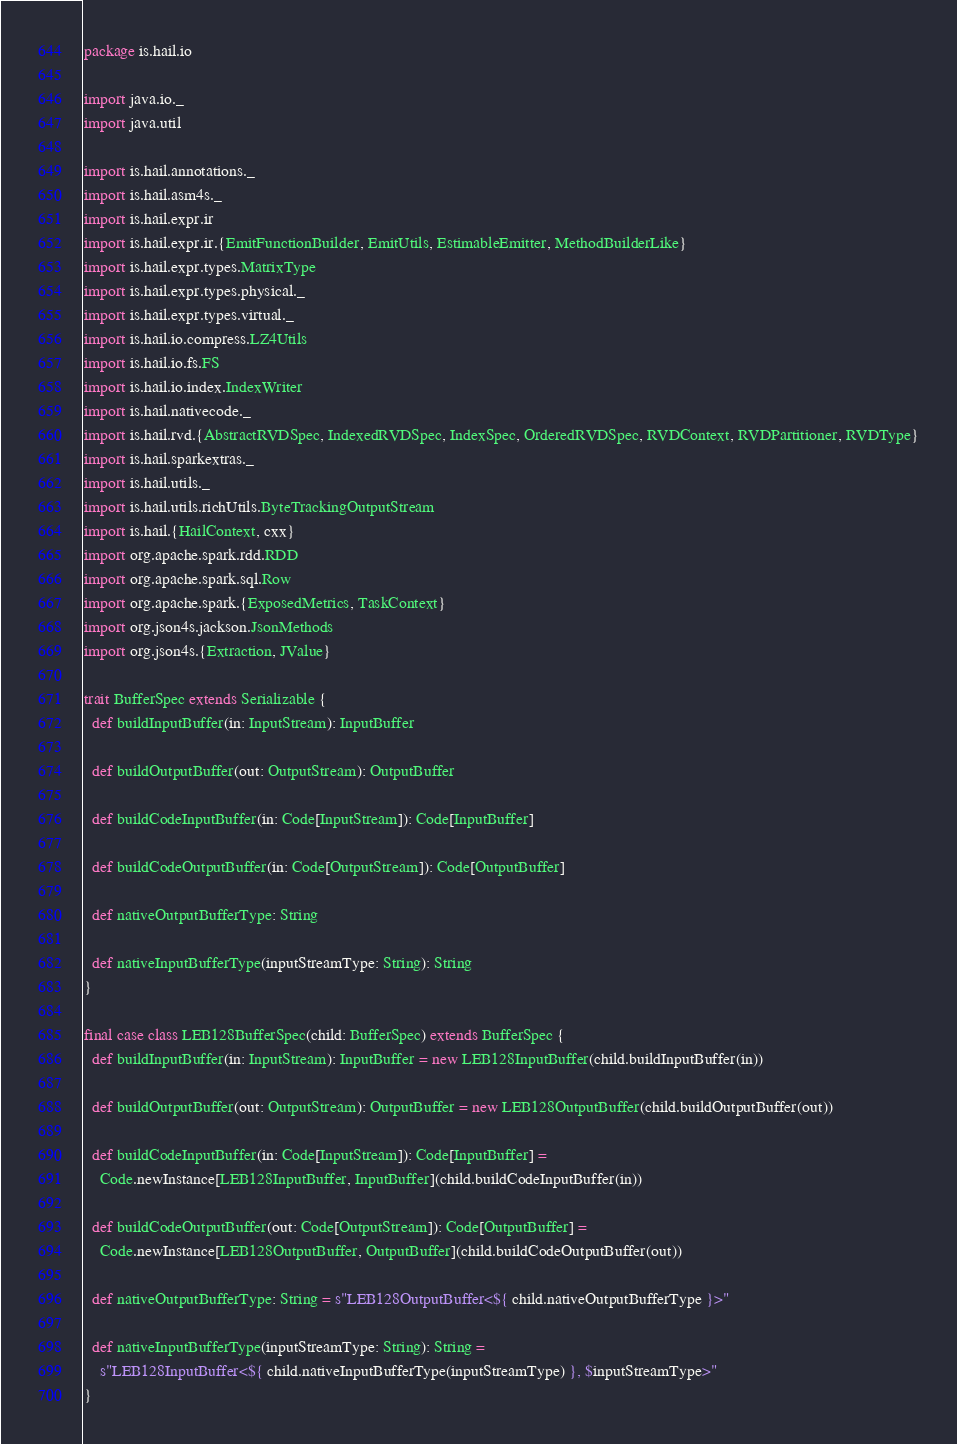Convert code to text. <code><loc_0><loc_0><loc_500><loc_500><_Scala_>package is.hail.io

import java.io._
import java.util

import is.hail.annotations._
import is.hail.asm4s._
import is.hail.expr.ir
import is.hail.expr.ir.{EmitFunctionBuilder, EmitUtils, EstimableEmitter, MethodBuilderLike}
import is.hail.expr.types.MatrixType
import is.hail.expr.types.physical._
import is.hail.expr.types.virtual._
import is.hail.io.compress.LZ4Utils
import is.hail.io.fs.FS
import is.hail.io.index.IndexWriter
import is.hail.nativecode._
import is.hail.rvd.{AbstractRVDSpec, IndexedRVDSpec, IndexSpec, OrderedRVDSpec, RVDContext, RVDPartitioner, RVDType}
import is.hail.sparkextras._
import is.hail.utils._
import is.hail.utils.richUtils.ByteTrackingOutputStream
import is.hail.{HailContext, cxx}
import org.apache.spark.rdd.RDD
import org.apache.spark.sql.Row
import org.apache.spark.{ExposedMetrics, TaskContext}
import org.json4s.jackson.JsonMethods
import org.json4s.{Extraction, JValue}

trait BufferSpec extends Serializable {
  def buildInputBuffer(in: InputStream): InputBuffer

  def buildOutputBuffer(out: OutputStream): OutputBuffer

  def buildCodeInputBuffer(in: Code[InputStream]): Code[InputBuffer]

  def buildCodeOutputBuffer(in: Code[OutputStream]): Code[OutputBuffer]

  def nativeOutputBufferType: String

  def nativeInputBufferType(inputStreamType: String): String
}

final case class LEB128BufferSpec(child: BufferSpec) extends BufferSpec {
  def buildInputBuffer(in: InputStream): InputBuffer = new LEB128InputBuffer(child.buildInputBuffer(in))

  def buildOutputBuffer(out: OutputStream): OutputBuffer = new LEB128OutputBuffer(child.buildOutputBuffer(out))

  def buildCodeInputBuffer(in: Code[InputStream]): Code[InputBuffer] =
    Code.newInstance[LEB128InputBuffer, InputBuffer](child.buildCodeInputBuffer(in))

  def buildCodeOutputBuffer(out: Code[OutputStream]): Code[OutputBuffer] =
    Code.newInstance[LEB128OutputBuffer, OutputBuffer](child.buildCodeOutputBuffer(out))

  def nativeOutputBufferType: String = s"LEB128OutputBuffer<${ child.nativeOutputBufferType }>"

  def nativeInputBufferType(inputStreamType: String): String =
    s"LEB128InputBuffer<${ child.nativeInputBufferType(inputStreamType) }, $inputStreamType>"
}
</code> 